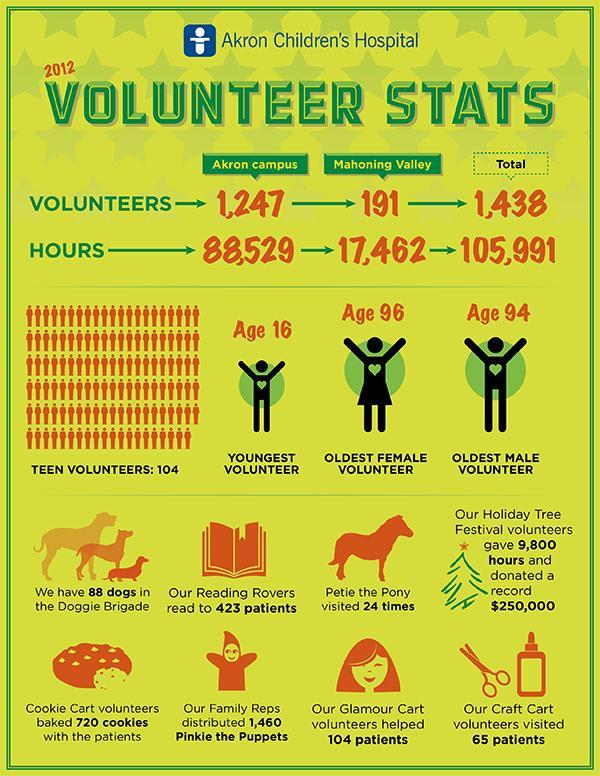What is the age of oldest male volunteer at Akron Children's Hospital in 2012?
Answer the question with a short phrase. Age 94 What is the total hours dedicated by the volunteers at Akron Children's Hospital in 2012? 105,991 What is the age of oldest female volunteer at Akron Children's Hospital in 2012? Age 96 How many patients were visited by the Craft Cart volunteers at Akron Children's Hospital in 2012? 65 patients What is the age of youngest volunteer at Akron Children's Hospital in 2012? Age 16 How many hours were dedicated by the volunteers at Akron Campus in 2012? 88,529 How many patients were helped by the glamour cart volunteers at Akron Children's Hospital in 2012? 104 How many volunteers were dedicated to work in the Mahoning Valley in 2012? 191 